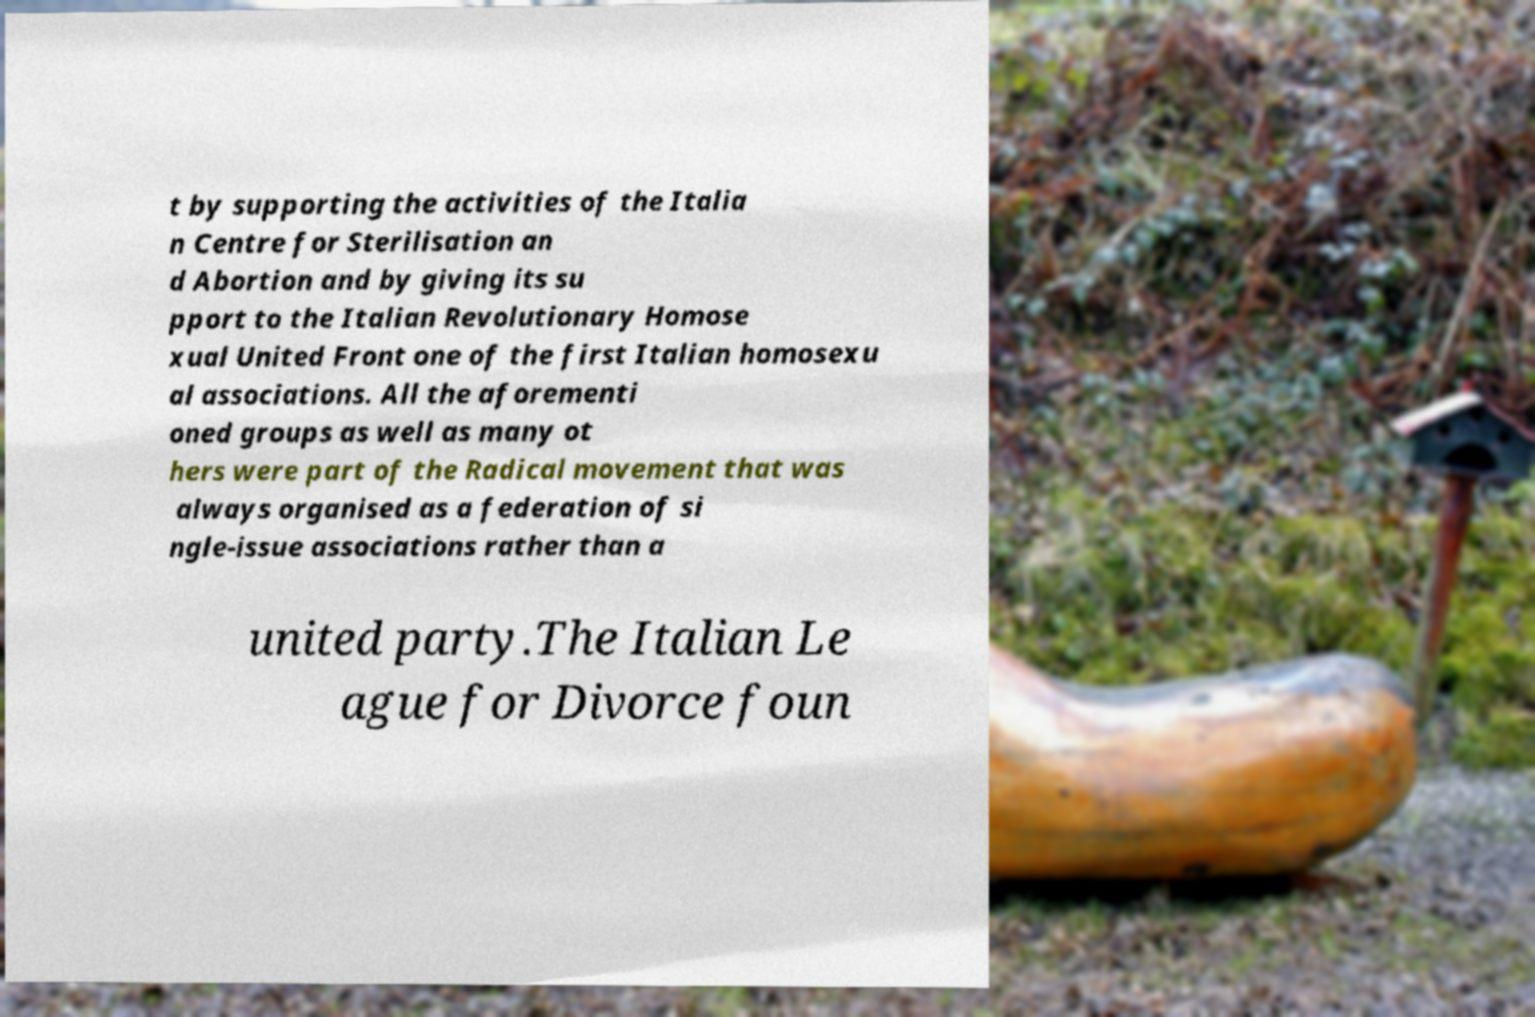Could you assist in decoding the text presented in this image and type it out clearly? t by supporting the activities of the Italia n Centre for Sterilisation an d Abortion and by giving its su pport to the Italian Revolutionary Homose xual United Front one of the first Italian homosexu al associations. All the aforementi oned groups as well as many ot hers were part of the Radical movement that was always organised as a federation of si ngle-issue associations rather than a united party.The Italian Le ague for Divorce foun 